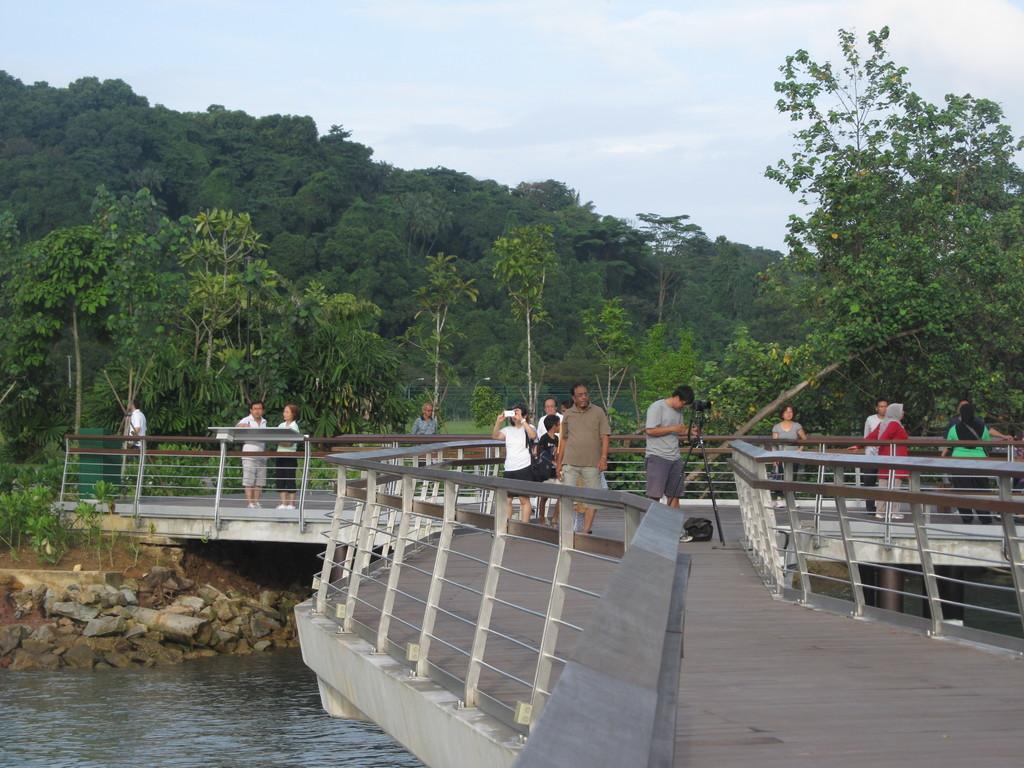Please provide a concise description of this image. In this image I can see number of people are standing. I can also see a black colour bag, a tripod and on it I can see a camera. I can also see water, number of stones and in the background I can see number of trees, clouds and the sky. 